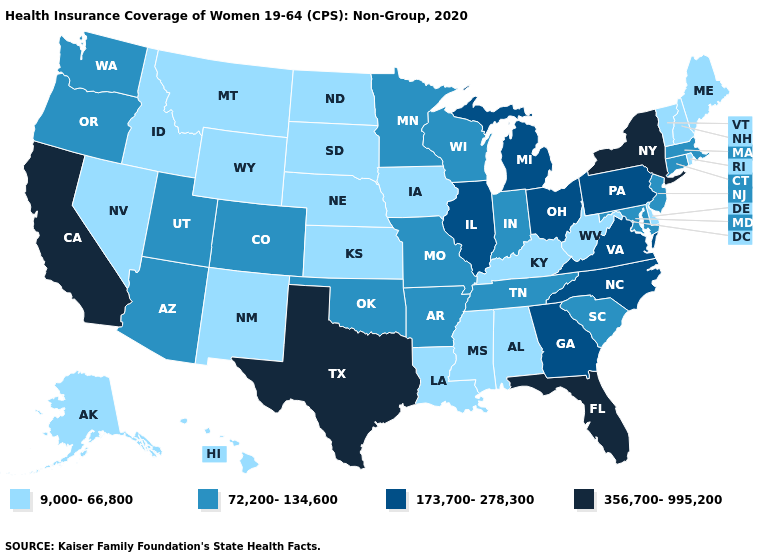How many symbols are there in the legend?
Short answer required. 4. Which states hav the highest value in the South?
Write a very short answer. Florida, Texas. Among the states that border Arkansas , which have the highest value?
Answer briefly. Texas. Name the states that have a value in the range 9,000-66,800?
Quick response, please. Alabama, Alaska, Delaware, Hawaii, Idaho, Iowa, Kansas, Kentucky, Louisiana, Maine, Mississippi, Montana, Nebraska, Nevada, New Hampshire, New Mexico, North Dakota, Rhode Island, South Dakota, Vermont, West Virginia, Wyoming. How many symbols are there in the legend?
Write a very short answer. 4. Name the states that have a value in the range 173,700-278,300?
Quick response, please. Georgia, Illinois, Michigan, North Carolina, Ohio, Pennsylvania, Virginia. What is the value of Maryland?
Quick response, please. 72,200-134,600. Which states have the lowest value in the West?
Short answer required. Alaska, Hawaii, Idaho, Montana, Nevada, New Mexico, Wyoming. Does Minnesota have the highest value in the MidWest?
Answer briefly. No. Which states have the lowest value in the Northeast?
Short answer required. Maine, New Hampshire, Rhode Island, Vermont. Name the states that have a value in the range 9,000-66,800?
Answer briefly. Alabama, Alaska, Delaware, Hawaii, Idaho, Iowa, Kansas, Kentucky, Louisiana, Maine, Mississippi, Montana, Nebraska, Nevada, New Hampshire, New Mexico, North Dakota, Rhode Island, South Dakota, Vermont, West Virginia, Wyoming. Does California have the highest value in the USA?
Be succinct. Yes. What is the value of Arkansas?
Be succinct. 72,200-134,600. Which states have the highest value in the USA?
Quick response, please. California, Florida, New York, Texas. What is the value of Connecticut?
Write a very short answer. 72,200-134,600. 